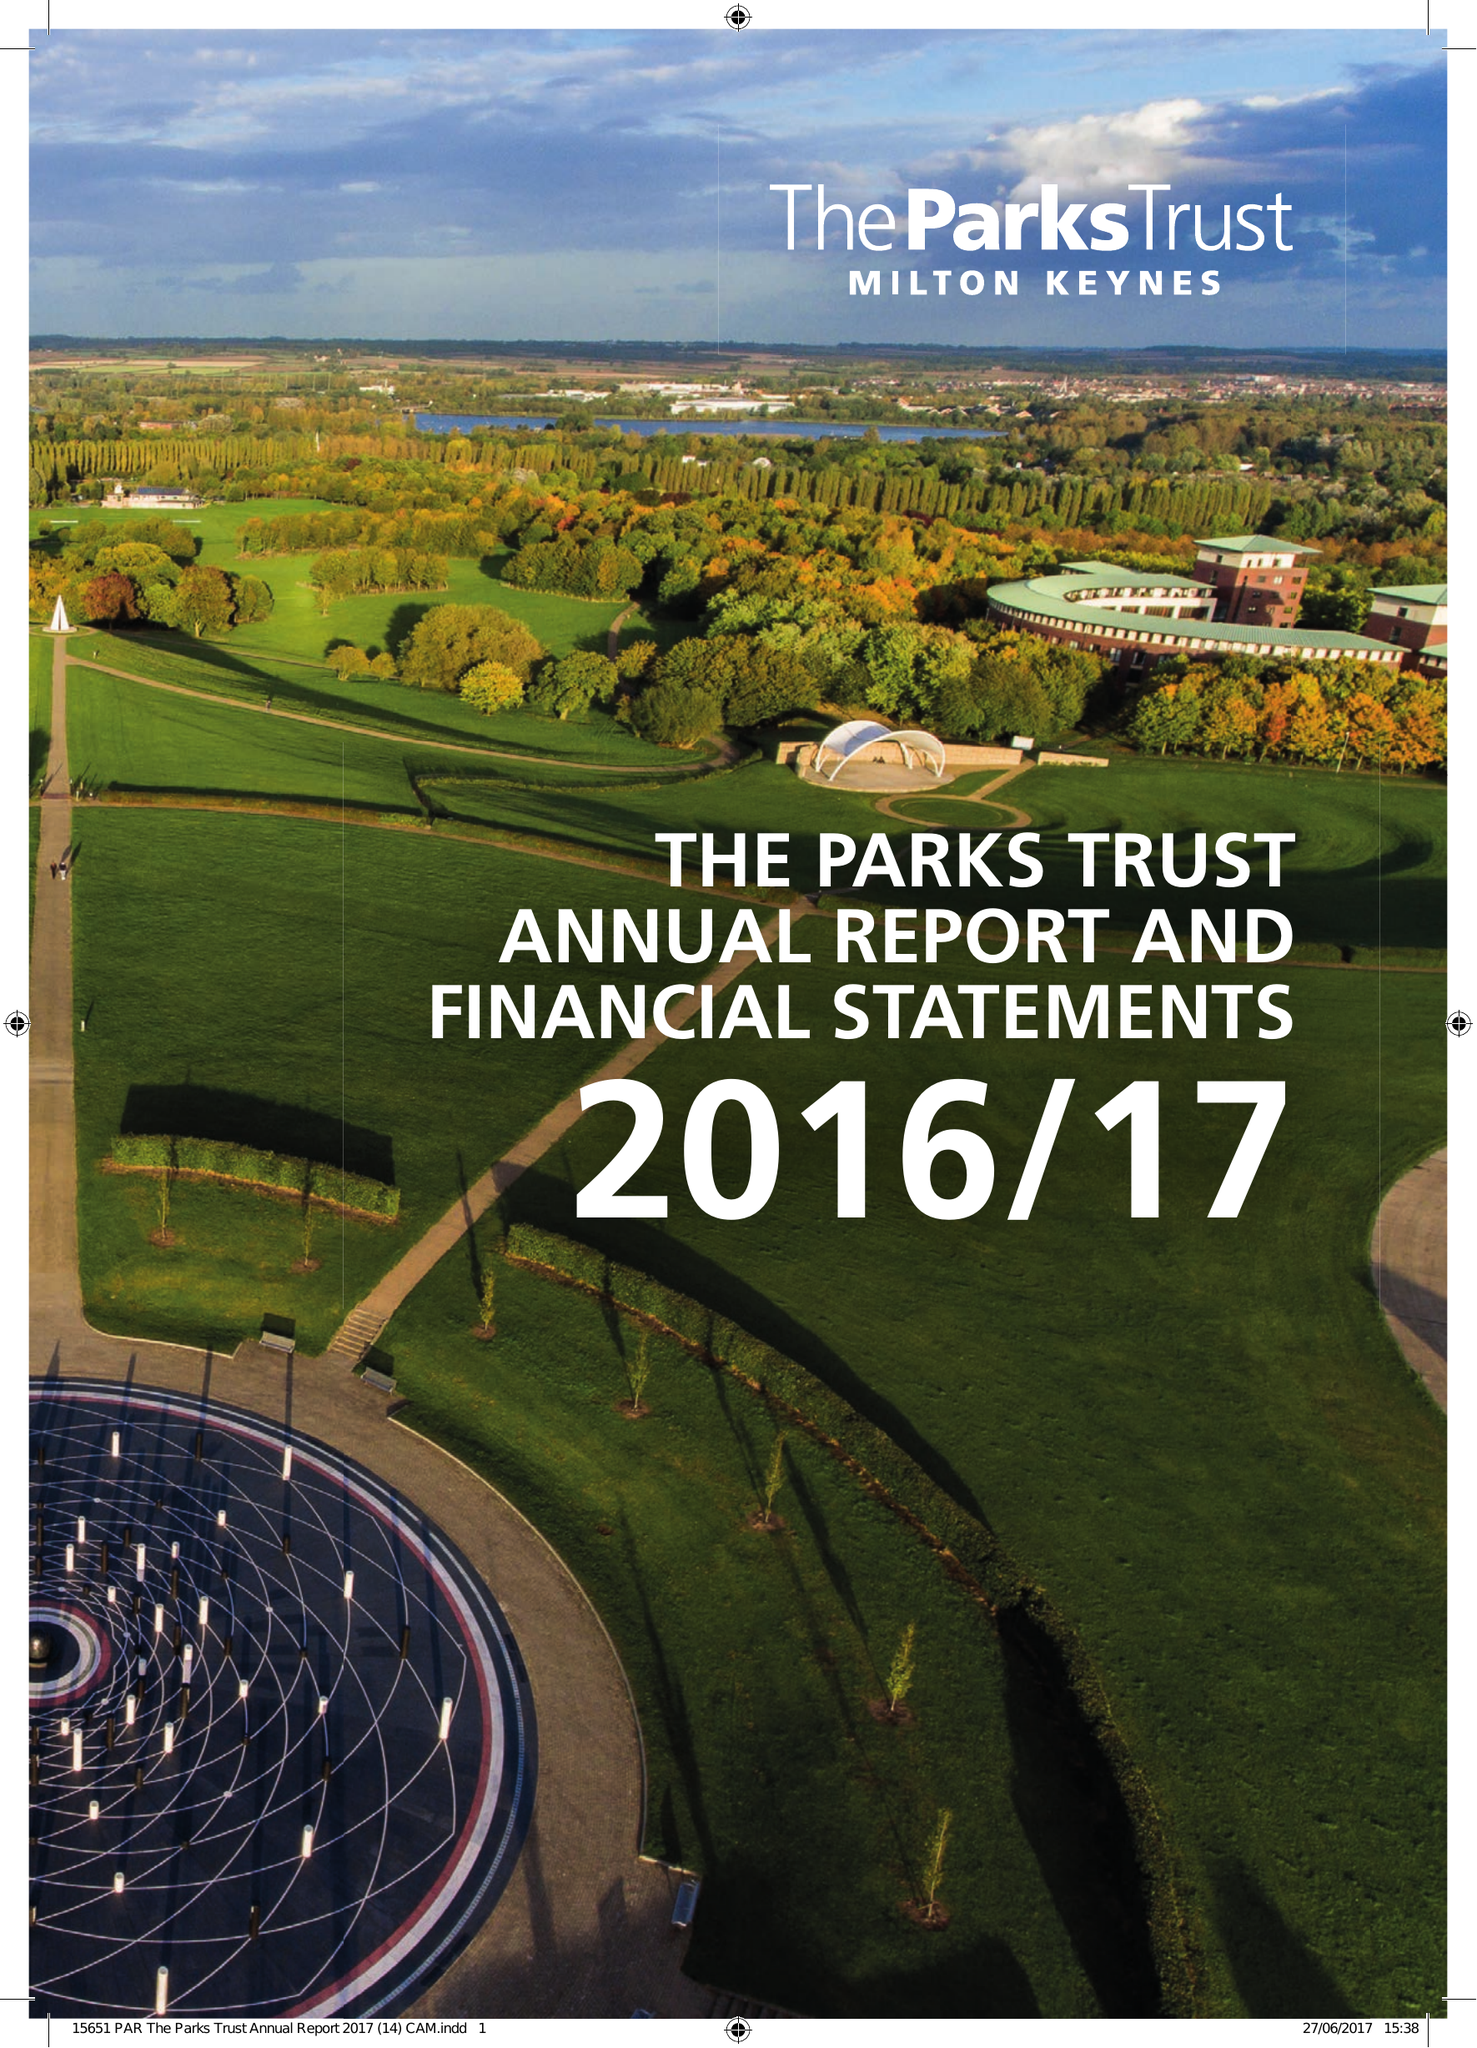What is the value for the report_date?
Answer the question using a single word or phrase. 2017-03-31 